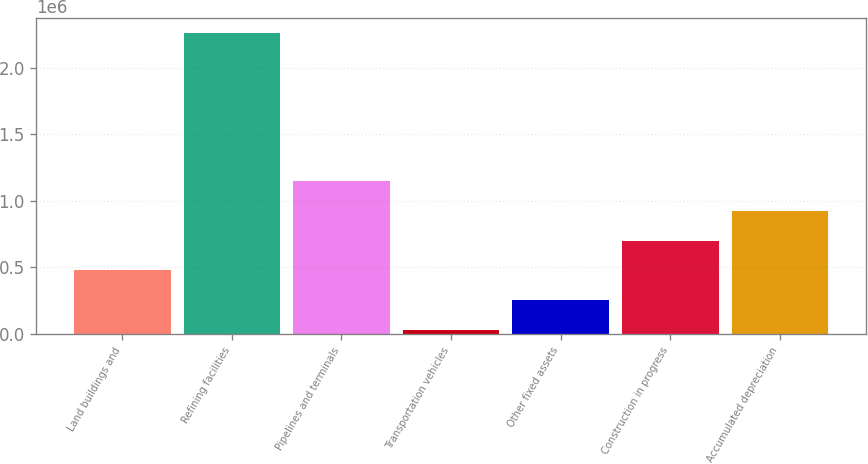Convert chart to OTSL. <chart><loc_0><loc_0><loc_500><loc_500><bar_chart><fcel>Land buildings and<fcel>Refining facilities<fcel>Pipelines and terminals<fcel>Transportation vehicles<fcel>Other fixed assets<fcel>Construction in progress<fcel>Accumulated depreciation<nl><fcel>476323<fcel>2.26173e+06<fcel>1.14585e+06<fcel>29970<fcel>253146<fcel>699499<fcel>922675<nl></chart> 